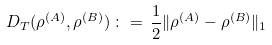<formula> <loc_0><loc_0><loc_500><loc_500>D _ { T } ( \rho ^ { ( A ) } , \rho ^ { ( B ) } ) \, \colon = \, \frac { 1 } { 2 } \| \rho ^ { ( A ) } - \rho ^ { ( B ) } \| _ { 1 }</formula> 